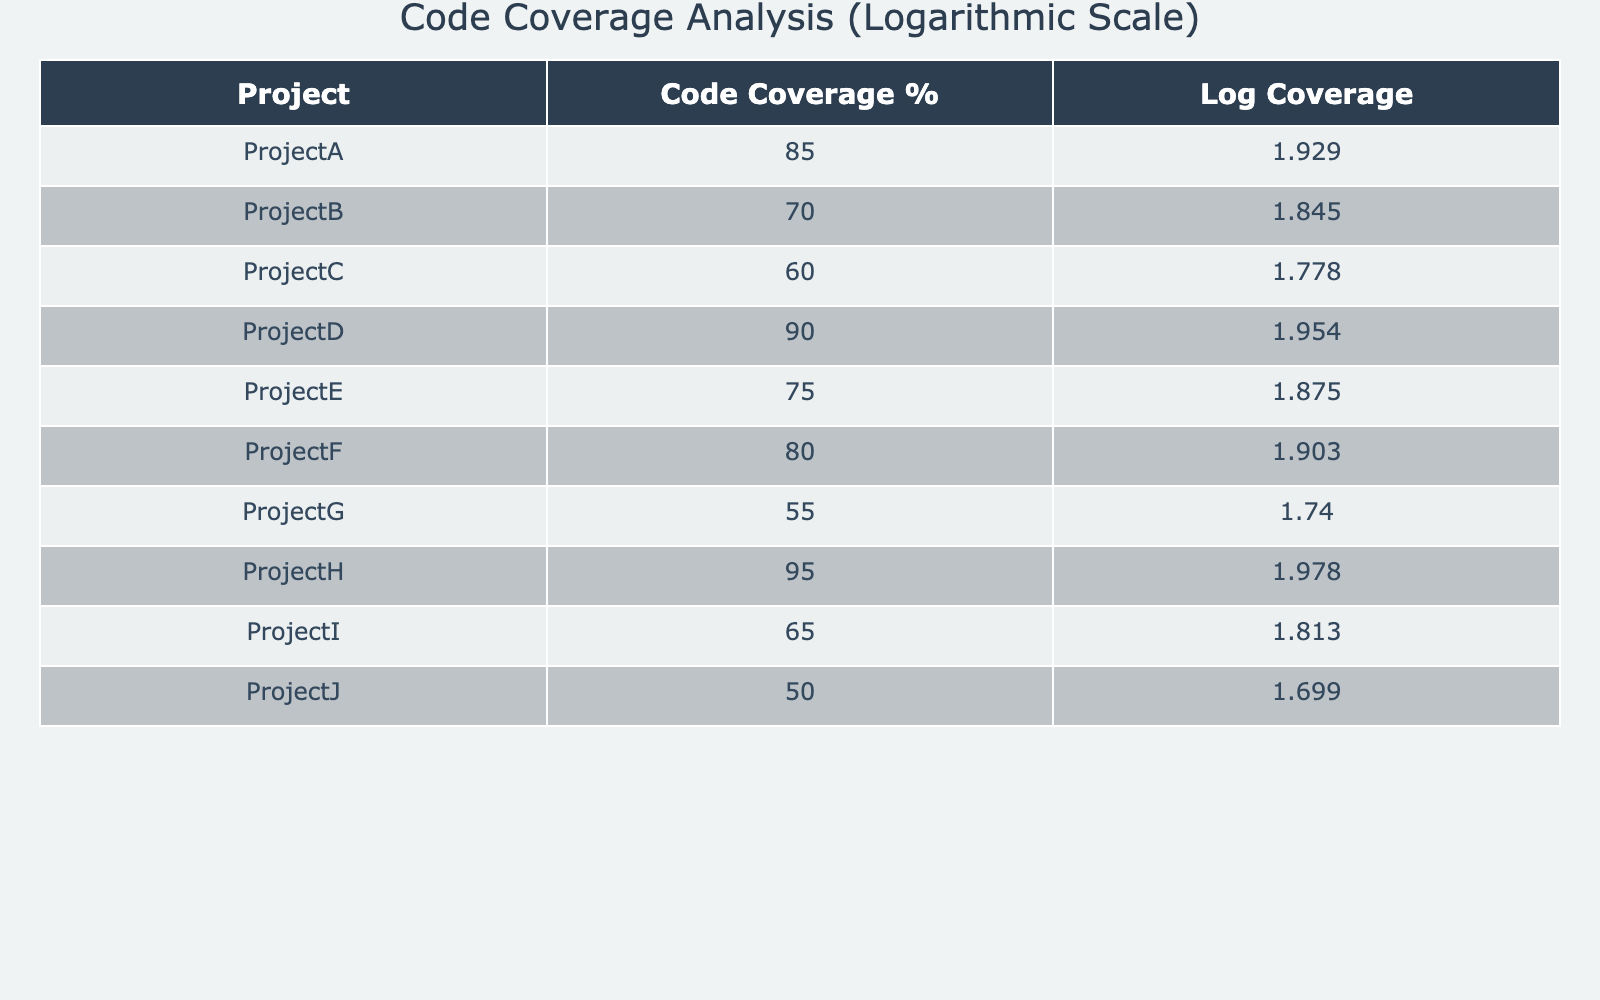What is the code coverage percentage of Project H? According to the table, Project H has a code coverage percentage of 95.
Answer: 95 Which project has the lowest code coverage percentage? The lowest code coverage percentage is found in Project J, which has a percentage of 50.
Answer: Project J What is the average code coverage percentage across all projects? To find the average, sum the coverage percentages: 85 + 70 + 60 + 90 + 75 + 80 + 55 + 95 + 65 + 50 = 825. There are 10 projects, so the average is 825 / 10 = 82.5.
Answer: 82.5 Is there any project with a code coverage percentage above 90? Yes, both Project D and Project H have code coverage percentages of 90 and 95, respectively, which are both above 90.
Answer: Yes What is the difference between the highest and lowest code coverage percentages? The highest code coverage percentage is 95 from Project H, and the lowest is 50 from Project J. The difference is calculated as 95 - 50 = 45.
Answer: 45 Which projects have a code coverage percentage above 80? The projects with a code coverage percentage above 80 are Project A (85), Project D (90) and Project H (95).
Answer: Project A, Project D, Project H What is the logarithmic value of the code coverage percentage for Project A? The logarithmic value for Project A's code coverage percentage (85) is calculated as log10(85) = 1.929.
Answer: 1.929 How many projects have a code coverage percentage below 70? The projects with a coverage percentage below 70 are Project B (70 but not below), Project C (60), Project G (55), and Project J (50). That totals to 3 projects below 70.
Answer: 3 Which project has a higher logarithmic coverage value, Project F or Project E? The logarithmic coverage for Project F (log10(80) = 1.903) is higher than that of Project E (log10(75) = 1.875). So Project F has a higher value.
Answer: Project F 